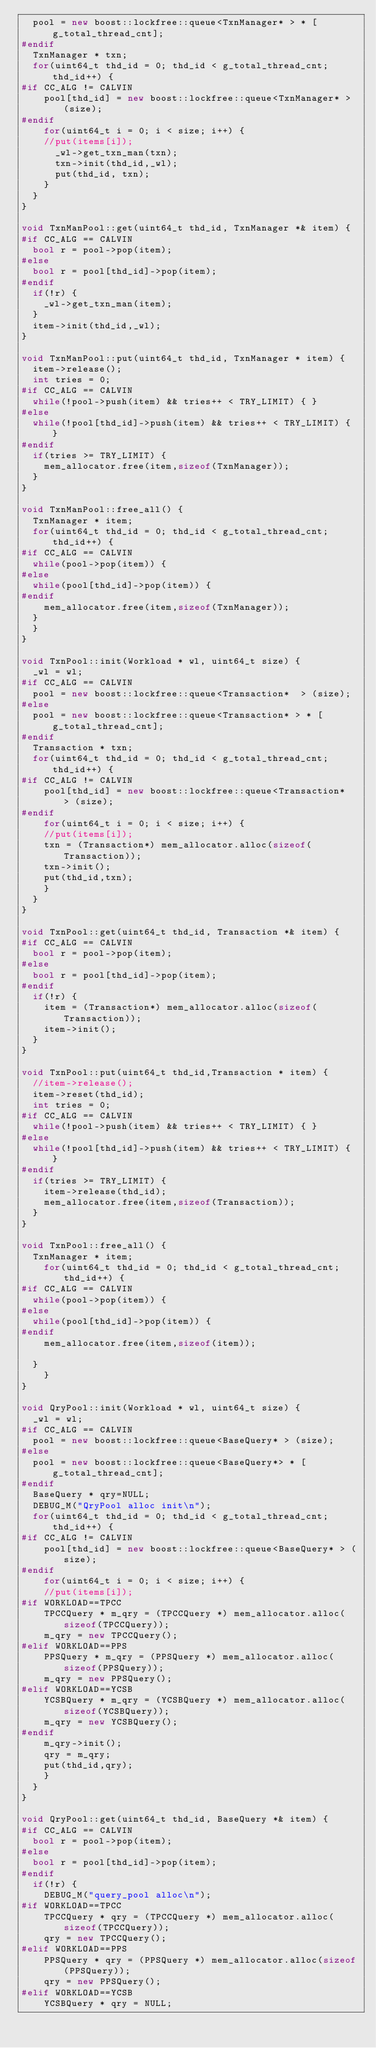Convert code to text. <code><loc_0><loc_0><loc_500><loc_500><_C++_>  pool = new boost::lockfree::queue<TxnManager* > * [g_total_thread_cnt];
#endif
  TxnManager * txn;
  for(uint64_t thd_id = 0; thd_id < g_total_thread_cnt; thd_id++) {
#if CC_ALG != CALVIN
    pool[thd_id] = new boost::lockfree::queue<TxnManager* > (size);
#endif
    for(uint64_t i = 0; i < size; i++) {
    //put(items[i]);
      _wl->get_txn_man(txn);
      txn->init(thd_id,_wl);
      put(thd_id, txn);
    }
  }
}

void TxnManPool::get(uint64_t thd_id, TxnManager *& item) {
#if CC_ALG == CALVIN
  bool r = pool->pop(item);
#else
  bool r = pool[thd_id]->pop(item);
#endif
  if(!r) {
    _wl->get_txn_man(item);
  }
  item->init(thd_id,_wl);
}

void TxnManPool::put(uint64_t thd_id, TxnManager * item) {
  item->release();
  int tries = 0;
#if CC_ALG == CALVIN
  while(!pool->push(item) && tries++ < TRY_LIMIT) { }
#else
  while(!pool[thd_id]->push(item) && tries++ < TRY_LIMIT) { }
#endif
  if(tries >= TRY_LIMIT) {
    mem_allocator.free(item,sizeof(TxnManager));
  }
}

void TxnManPool::free_all() {
  TxnManager * item;
  for(uint64_t thd_id = 0; thd_id < g_total_thread_cnt; thd_id++) {
#if CC_ALG == CALVIN
  while(pool->pop(item)) {
#else
  while(pool[thd_id]->pop(item)) {
#endif
    mem_allocator.free(item,sizeof(TxnManager));
  }
  }
}

void TxnPool::init(Workload * wl, uint64_t size) {
  _wl = wl;
#if CC_ALG == CALVIN
  pool = new boost::lockfree::queue<Transaction*  > (size);
#else
  pool = new boost::lockfree::queue<Transaction* > * [g_total_thread_cnt];
#endif
  Transaction * txn;
  for(uint64_t thd_id = 0; thd_id < g_total_thread_cnt; thd_id++) {
#if CC_ALG != CALVIN
    pool[thd_id] = new boost::lockfree::queue<Transaction*  > (size);
#endif
    for(uint64_t i = 0; i < size; i++) {
    //put(items[i]);
    txn = (Transaction*) mem_allocator.alloc(sizeof(Transaction));
    txn->init();
    put(thd_id,txn);
    }
  }
}

void TxnPool::get(uint64_t thd_id, Transaction *& item) {
#if CC_ALG == CALVIN
  bool r = pool->pop(item);
#else
  bool r = pool[thd_id]->pop(item);
#endif
  if(!r) {
    item = (Transaction*) mem_allocator.alloc(sizeof(Transaction));
    item->init();
  }
}

void TxnPool::put(uint64_t thd_id,Transaction * item) {
  //item->release();
  item->reset(thd_id);
  int tries = 0;
#if CC_ALG == CALVIN
  while(!pool->push(item) && tries++ < TRY_LIMIT) { }
#else
  while(!pool[thd_id]->push(item) && tries++ < TRY_LIMIT) { }
#endif
  if(tries >= TRY_LIMIT) {
    item->release(thd_id);
    mem_allocator.free(item,sizeof(Transaction));
  }
}

void TxnPool::free_all() {
  TxnManager * item;
    for(uint64_t thd_id = 0; thd_id < g_total_thread_cnt; thd_id++) {
#if CC_ALG == CALVIN
  while(pool->pop(item)) {
#else
  while(pool[thd_id]->pop(item)) {
#endif
    mem_allocator.free(item,sizeof(item));

  }
    }
}

void QryPool::init(Workload * wl, uint64_t size) {
  _wl = wl;
#if CC_ALG == CALVIN
  pool = new boost::lockfree::queue<BaseQuery* > (size);
#else
  pool = new boost::lockfree::queue<BaseQuery*> * [g_total_thread_cnt];
#endif
  BaseQuery * qry=NULL;
  DEBUG_M("QryPool alloc init\n");
  for(uint64_t thd_id = 0; thd_id < g_total_thread_cnt; thd_id++) {
#if CC_ALG != CALVIN
    pool[thd_id] = new boost::lockfree::queue<BaseQuery* > (size);
#endif
    for(uint64_t i = 0; i < size; i++) {
    //put(items[i]);
#if WORKLOAD==TPCC
    TPCCQuery * m_qry = (TPCCQuery *) mem_allocator.alloc(sizeof(TPCCQuery));
    m_qry = new TPCCQuery();
#elif WORKLOAD==PPS
    PPSQuery * m_qry = (PPSQuery *) mem_allocator.alloc(sizeof(PPSQuery));
    m_qry = new PPSQuery();
#elif WORKLOAD==YCSB
    YCSBQuery * m_qry = (YCSBQuery *) mem_allocator.alloc(sizeof(YCSBQuery));
    m_qry = new YCSBQuery();
#endif
    m_qry->init();
    qry = m_qry;
    put(thd_id,qry);
    }
  }
}

void QryPool::get(uint64_t thd_id, BaseQuery *& item) {
#if CC_ALG == CALVIN
  bool r = pool->pop(item);
#else
  bool r = pool[thd_id]->pop(item);
#endif
  if(!r) {
    DEBUG_M("query_pool alloc\n");
#if WORKLOAD==TPCC
    TPCCQuery * qry = (TPCCQuery *) mem_allocator.alloc(sizeof(TPCCQuery));
    qry = new TPCCQuery();
#elif WORKLOAD==PPS
    PPSQuery * qry = (PPSQuery *) mem_allocator.alloc(sizeof(PPSQuery));
    qry = new PPSQuery();
#elif WORKLOAD==YCSB
    YCSBQuery * qry = NULL;</code> 